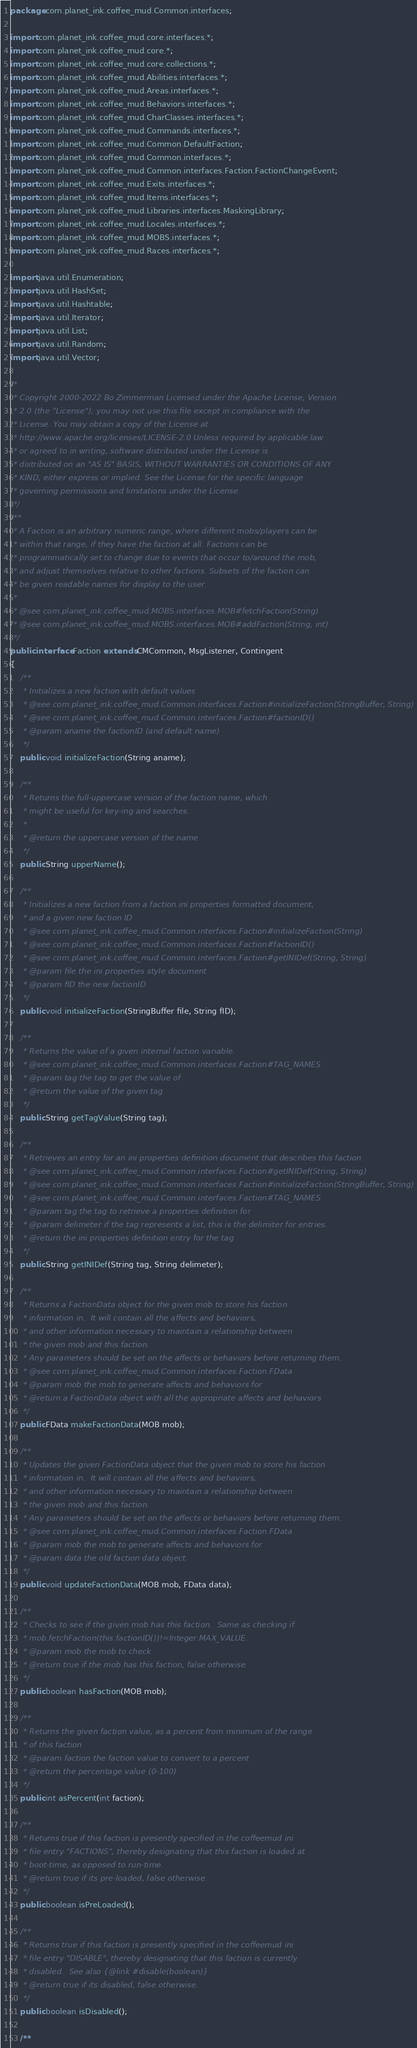Convert code to text. <code><loc_0><loc_0><loc_500><loc_500><_Java_>package com.planet_ink.coffee_mud.Common.interfaces;

import com.planet_ink.coffee_mud.core.interfaces.*;
import com.planet_ink.coffee_mud.core.*;
import com.planet_ink.coffee_mud.core.collections.*;
import com.planet_ink.coffee_mud.Abilities.interfaces.*;
import com.planet_ink.coffee_mud.Areas.interfaces.*;
import com.planet_ink.coffee_mud.Behaviors.interfaces.*;
import com.planet_ink.coffee_mud.CharClasses.interfaces.*;
import com.planet_ink.coffee_mud.Commands.interfaces.*;
import com.planet_ink.coffee_mud.Common.DefaultFaction;
import com.planet_ink.coffee_mud.Common.interfaces.*;
import com.planet_ink.coffee_mud.Common.interfaces.Faction.FactionChangeEvent;
import com.planet_ink.coffee_mud.Exits.interfaces.*;
import com.planet_ink.coffee_mud.Items.interfaces.*;
import com.planet_ink.coffee_mud.Libraries.interfaces.MaskingLibrary;
import com.planet_ink.coffee_mud.Locales.interfaces.*;
import com.planet_ink.coffee_mud.MOBS.interfaces.*;
import com.planet_ink.coffee_mud.Races.interfaces.*;

import java.util.Enumeration;
import java.util.HashSet;
import java.util.Hashtable;
import java.util.Iterator;
import java.util.List;
import java.util.Random;
import java.util.Vector;

/*
 * Copyright 2000-2022 Bo Zimmerman Licensed under the Apache License, Version
 * 2.0 (the "License"); you may not use this file except in compliance with the
 * License. You may obtain a copy of the License at
 * http://www.apache.org/licenses/LICENSE-2.0 Unless required by applicable law
 * or agreed to in writing, software distributed under the License is
 * distributed on an "AS IS" BASIS, WITHOUT WARRANTIES OR CONDITIONS OF ANY
 * KIND, either express or implied. See the License for the specific language
 * governing permissions and limitations under the License.
 */
/**
 * A Faction is an arbitrary numeric range, where different mobs/players can be
 * within that range, if they have the faction at all. Factions can be
 * programmatically set to change due to events that occur to/around the mob,
 * and adjust themselves relative to other factions. Subsets of the faction can
 * be given readable names for display to the user.
 *
 * @see com.planet_ink.coffee_mud.MOBS.interfaces.MOB#fetchFaction(String)
 * @see com.planet_ink.coffee_mud.MOBS.interfaces.MOB#addFaction(String, int)
 */
public interface Faction extends CMCommon, MsgListener, Contingent
{
	/**
	 * Initializes a new faction with default values
	 * @see com.planet_ink.coffee_mud.Common.interfaces.Faction#initializeFaction(StringBuffer, String)
	 * @see com.planet_ink.coffee_mud.Common.interfaces.Faction#factionID()
	 * @param aname the factionID (and default name)
	 */
	public void initializeFaction(String aname);

	/**
	 * Returns the full-uppercase version of the faction name, which
	 * might be useful for key-ing and searches.
	 *
	 * @return the uppercase version of the name
	 */
	public String upperName();

	/**
	 * Initializes a new faction from a faction.ini properties formatted document,
	 * and a given new faction ID
	 * @see com.planet_ink.coffee_mud.Common.interfaces.Faction#initializeFaction(String)
	 * @see com.planet_ink.coffee_mud.Common.interfaces.Faction#factionID()
	 * @see com.planet_ink.coffee_mud.Common.interfaces.Faction#getINIDef(String, String)
	 * @param file the ini properties style document
	 * @param fID the new factionID
	 */
	public void initializeFaction(StringBuffer file, String fID);

	/**
	 * Returns the value of a given internal faction variable.
	 * @see com.planet_ink.coffee_mud.Common.interfaces.Faction#TAG_NAMES
	 * @param tag the tag to get the value of
	 * @return the value of the given tag
	 */
	public String getTagValue(String tag);

	/**
	 * Retrieves an entry for an ini properties definition document that describes this faction.
	 * @see com.planet_ink.coffee_mud.Common.interfaces.Faction#getINIDef(String, String)
	 * @see com.planet_ink.coffee_mud.Common.interfaces.Faction#initializeFaction(StringBuffer, String)
	 * @see com.planet_ink.coffee_mud.Common.interfaces.Faction#TAG_NAMES
	 * @param tag the tag to retrieve a properties definition for
	 * @param delimeter if the tag represents a list, this is the delimiter for entries.
	 * @return the ini properties definition entry for the tag
	 */
	public String getINIDef(String tag, String delimeter);

	/**
	 * Returns a FactionData object for the given mob to store his faction
	 * information in.  It will contain all the affects and behaviors,
	 * and other information necessary to maintain a relationship between
	 * the given mob and this faction.
	 * Any parameters should be set on the affects or behaviors before returning them.
	 * @see com.planet_ink.coffee_mud.Common.interfaces.Faction.FData
	 * @param mob the mob to generate affects and behaviors for
	 * @return a FactionData object with all the appropriate affects and behaviors
	 */
	public FData makeFactionData(MOB mob);

	/**
	 * Updates the given FactionData object that the given mob to store his faction
	 * information in.  It will contain all the affects and behaviors,
	 * and other information necessary to maintain a relationship between
	 * the given mob and this faction.
	 * Any parameters should be set on the affects or behaviors before returning them.
	 * @see com.planet_ink.coffee_mud.Common.interfaces.Faction.FData
	 * @param mob the mob to generate affects and behaviors for
	 * @param data the old faction data object
	 */
	public void updateFactionData(MOB mob, FData data);

	/**
	 * Checks to see if the given mob has this faction.  Same as checking if
	 * mob.fetchFaction(this.factionID())!=Integer.MAX_VALUE.
	 * @param mob the mob to check
	 * @return true if the mob has this faction, false otherwise
	 */
	public boolean hasFaction(MOB mob);

	/**
	 * Returns the given faction value, as a percent from minimum of the range
	 * of this faction
	 * @param faction the faction value to convert to a percent
	 * @return the percentage value (0-100)
	 */
	public int asPercent(int faction);

	/**
	 * Returns true if this faction is presently specified in the coffeemud ini
	 * file entry "FACTIONS", thereby designating that this faction is loaded at
	 * boot-time, as opposed to run-time.
	 * @return true if its pre-loaded, false otherwise.
	 */
	public boolean isPreLoaded();

	/**
	 * Returns true if this faction is presently specified in the coffeemud ini
	 * file entry "DISABLE", thereby designating that this faction is currently
	 * disabled.  See also {@link #disable(boolean)}
	 * @return true if its disabled, false otherwise.
	 */
	public boolean isDisabled();

	/**</code> 